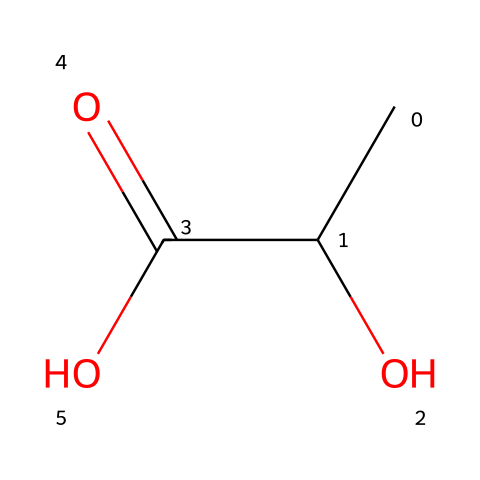What is the molecular formula of this compound? The SMILES representation CC(O)C(=O)O can be broken down to determine the molecular formula. The two C's in CC indicate there are 2 carbon atoms. The (O) indicates one hydroxyl (-OH) group, and C(=O)O indicates a carbon that is double-bonded to one oxygen (part of a carboxylic acid) and single-bonded to another oxygen (part of another hydroxyl group). Thus, counting the atoms gives 3 C, 6 H, and 3 O atoms total.
Answer: C3H6O3 How many hydrogen atoms are in this acid? In the decomposition of the SMILES CC(O)C(=O)O, each carbon atom (C) can bond with up to four hydrogen atoms (H) because it is tetravalent. Observing the structure, we determine 6 hydrogen atoms are present overall.
Answer: 6 What type of functional groups are present in this structure? Analyzing the structure of this compound from the SMILES, we see it contains a carboxylic acid functional group (−COOH) identified by C(=O)O and a hydroxyl group (−OH) indicated by O directly attached to a carbon. Therefore, the functional groups are carboxylic acid and hydroxyl.
Answer: carboxylic acid, hydroxyl Is this compound an organic or inorganic acid? From the structural information provided in the SMILES, we can identify that this compound is composed of carbon (C), hydrogen (H), and oxygen (O) atoms, which are characteristic of organic compounds. Since it has a carbon-based structure, it is classified as an organic acid.
Answer: organic What is the acidity level of lactic acid, generally speaking? Based on the presence of the carboxylic acid functional group in the structure (C(=O)O), which typically donates protons (H+) in solution, lactic acid is classified as a weak acid. The relative strength is measured often by its pKa value, which for lactic acid is around 3.86, indicating its acidity level.
Answer: weak acid How would you classify lactic acid in terms of its solubility in water? Given that lactic acid contains hydroxyl and carboxylic acid groups, it is expected to be hydrophilic due to its ability to form hydrogen bonds with water. Therefore, lactic acid is known to be highly soluble in water.
Answer: highly soluble What is the significance of lactic acid in sports drinks? Lactic acid helps to provide energy during exercise and is often included in sports drinks to assist with endurance and recovery. Its presence aids in regulating pH levels and electrolyte balance, making it beneficial for athletes.
Answer: energy source 